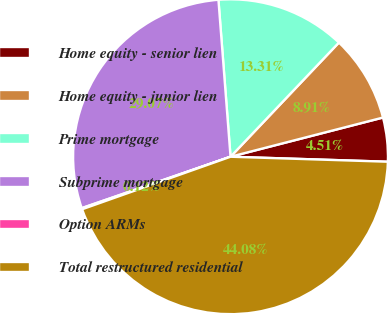Convert chart to OTSL. <chart><loc_0><loc_0><loc_500><loc_500><pie_chart><fcel>Home equity - senior lien<fcel>Home equity - junior lien<fcel>Prime mortgage<fcel>Subprime mortgage<fcel>Option ARMs<fcel>Total restructured residential<nl><fcel>4.51%<fcel>8.91%<fcel>13.31%<fcel>29.07%<fcel>0.12%<fcel>44.08%<nl></chart> 